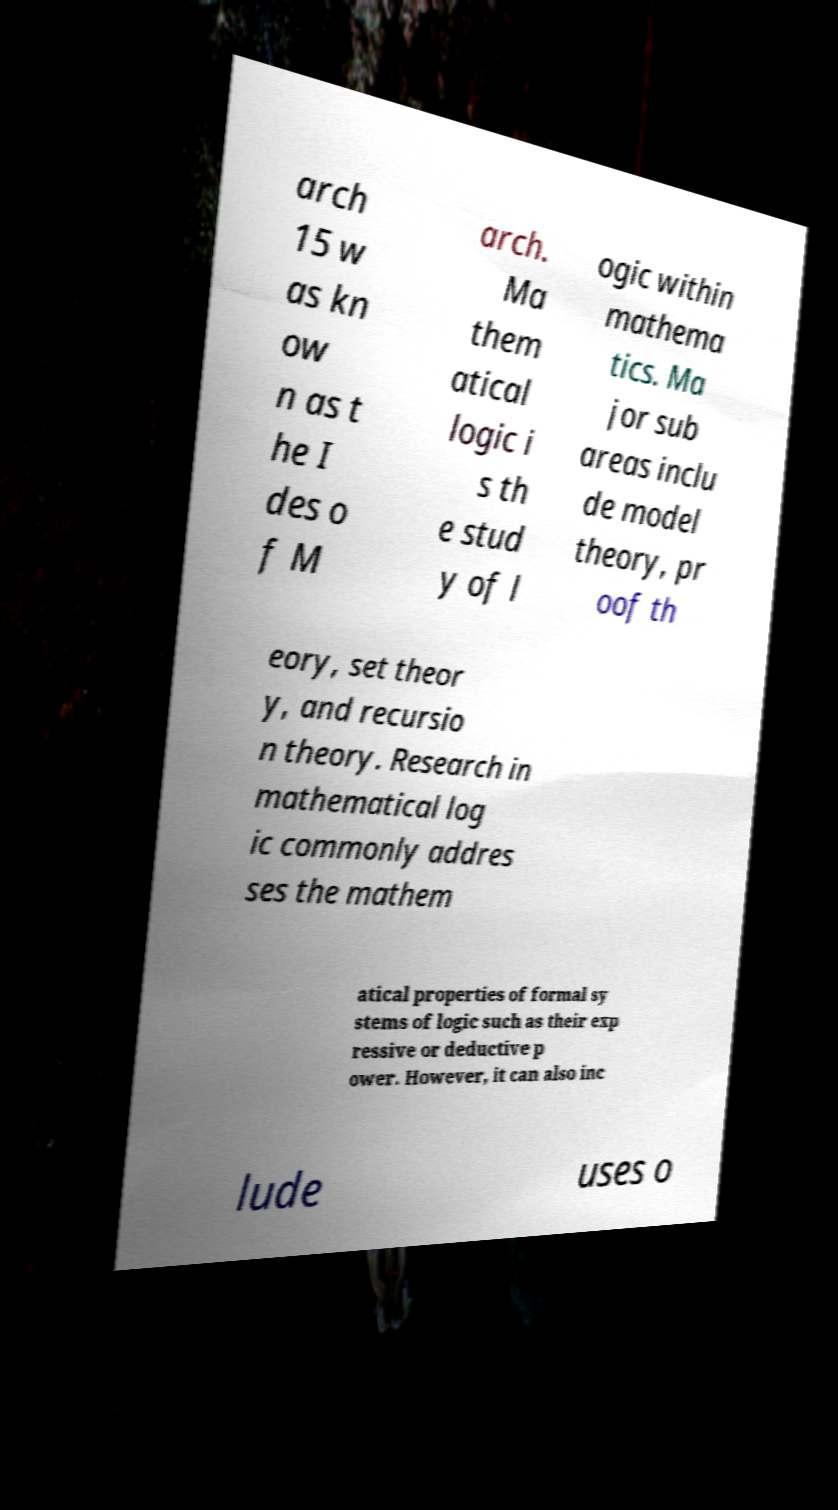I need the written content from this picture converted into text. Can you do that? arch 15 w as kn ow n as t he I des o f M arch. Ma them atical logic i s th e stud y of l ogic within mathema tics. Ma jor sub areas inclu de model theory, pr oof th eory, set theor y, and recursio n theory. Research in mathematical log ic commonly addres ses the mathem atical properties of formal sy stems of logic such as their exp ressive or deductive p ower. However, it can also inc lude uses o 